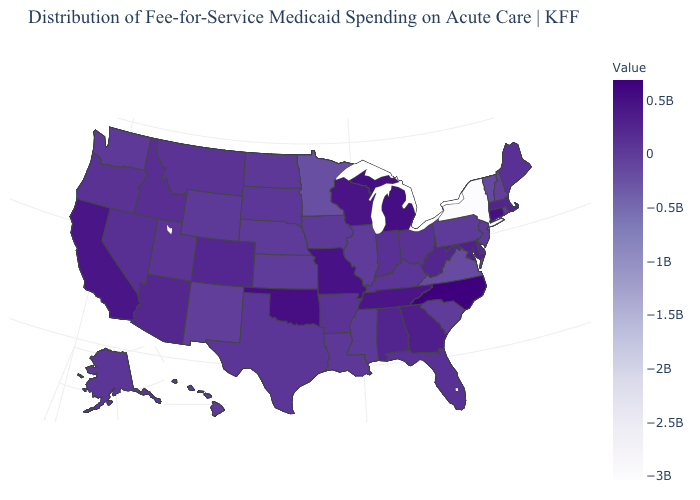Among the states that border North Carolina , does Tennessee have the highest value?
Write a very short answer. Yes. Which states have the lowest value in the USA?
Short answer required. New York. Among the states that border Oklahoma , which have the lowest value?
Be succinct. New Mexico. Does Nevada have the highest value in the USA?
Write a very short answer. No. Among the states that border Nevada , which have the highest value?
Keep it brief. California. 